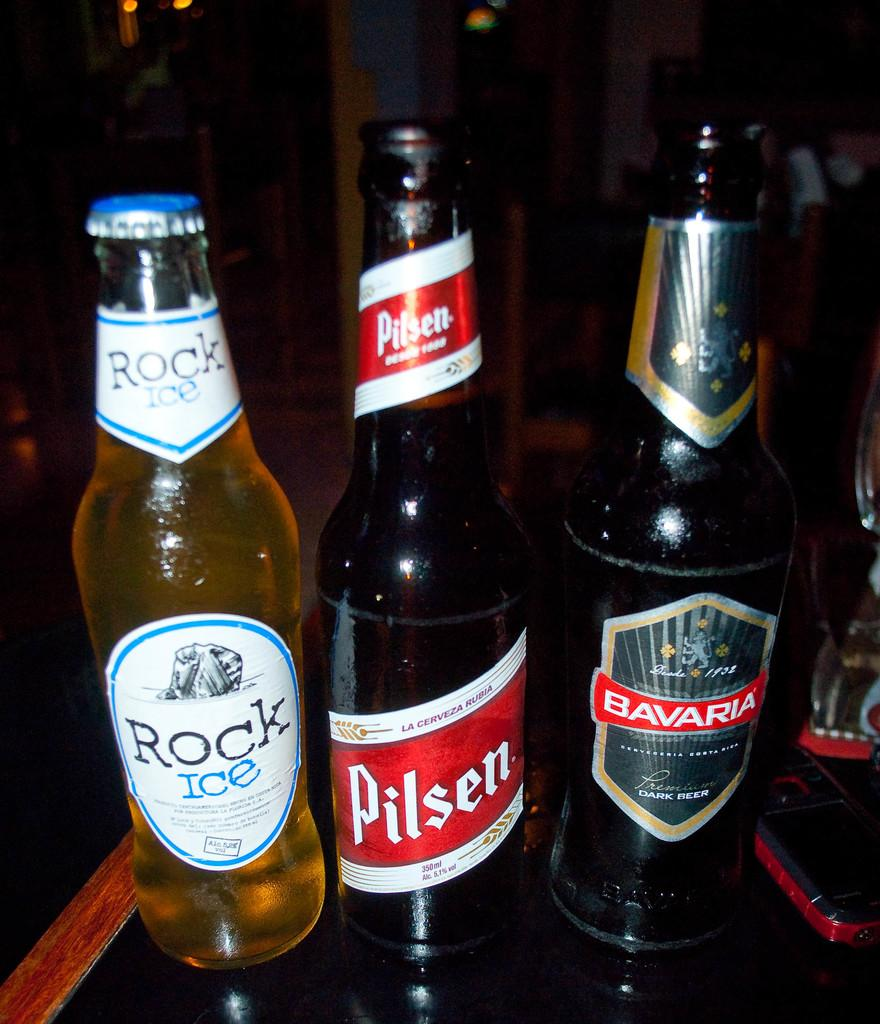<image>
Describe the image concisely. A bottle of Rock Ice, Pilsen, and Bavaria are lined up next to each other. 